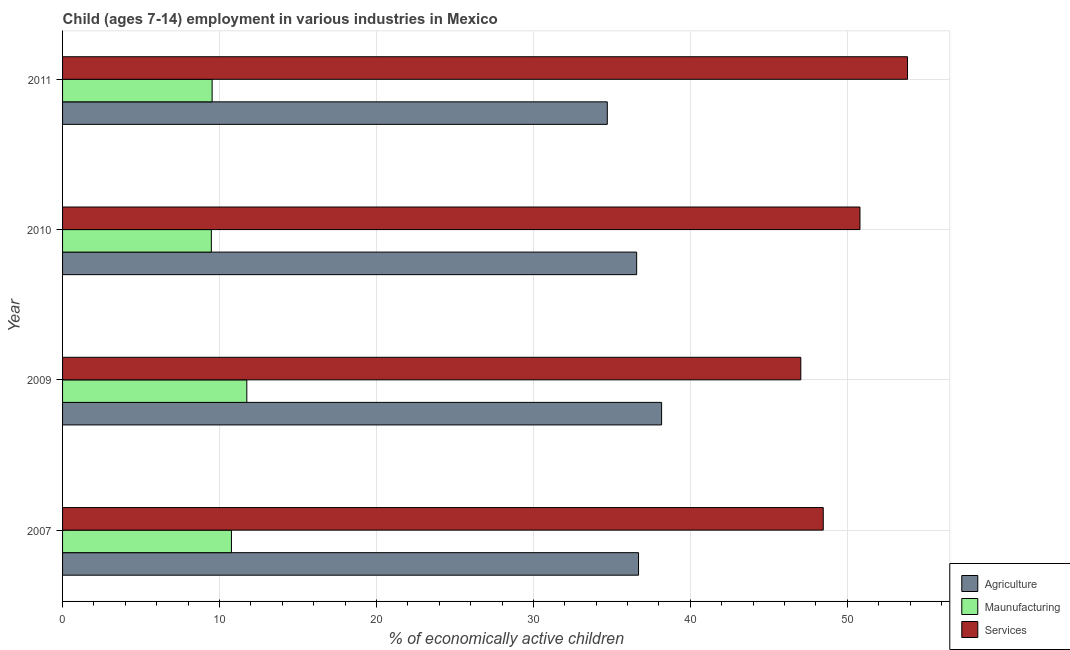Are the number of bars per tick equal to the number of legend labels?
Offer a very short reply. Yes. How many bars are there on the 3rd tick from the top?
Make the answer very short. 3. How many bars are there on the 1st tick from the bottom?
Offer a very short reply. 3. What is the label of the 3rd group of bars from the top?
Your answer should be compact. 2009. What is the percentage of economically active children in services in 2010?
Provide a succinct answer. 50.81. Across all years, what is the maximum percentage of economically active children in manufacturing?
Provide a succinct answer. 11.74. Across all years, what is the minimum percentage of economically active children in manufacturing?
Provide a short and direct response. 9.48. In which year was the percentage of economically active children in services maximum?
Your answer should be compact. 2011. What is the total percentage of economically active children in manufacturing in the graph?
Provide a short and direct response. 41.51. What is the difference between the percentage of economically active children in services in 2007 and that in 2011?
Offer a very short reply. -5.37. What is the difference between the percentage of economically active children in agriculture in 2010 and the percentage of economically active children in services in 2009?
Offer a terse response. -10.46. What is the average percentage of economically active children in manufacturing per year?
Ensure brevity in your answer.  10.38. In the year 2009, what is the difference between the percentage of economically active children in agriculture and percentage of economically active children in services?
Provide a short and direct response. -8.87. What is the ratio of the percentage of economically active children in agriculture in 2010 to that in 2011?
Make the answer very short. 1.05. Is the difference between the percentage of economically active children in services in 2009 and 2011 greater than the difference between the percentage of economically active children in manufacturing in 2009 and 2011?
Your response must be concise. No. What is the difference between the highest and the second highest percentage of economically active children in services?
Your answer should be compact. 3.03. In how many years, is the percentage of economically active children in manufacturing greater than the average percentage of economically active children in manufacturing taken over all years?
Your response must be concise. 2. What does the 3rd bar from the top in 2011 represents?
Your response must be concise. Agriculture. What does the 3rd bar from the bottom in 2010 represents?
Offer a terse response. Services. Is it the case that in every year, the sum of the percentage of economically active children in agriculture and percentage of economically active children in manufacturing is greater than the percentage of economically active children in services?
Your response must be concise. No. Are all the bars in the graph horizontal?
Your response must be concise. Yes. How many years are there in the graph?
Make the answer very short. 4. What is the difference between two consecutive major ticks on the X-axis?
Ensure brevity in your answer.  10. Are the values on the major ticks of X-axis written in scientific E-notation?
Make the answer very short. No. How many legend labels are there?
Give a very brief answer. 3. What is the title of the graph?
Your answer should be very brief. Child (ages 7-14) employment in various industries in Mexico. Does "Primary education" appear as one of the legend labels in the graph?
Make the answer very short. No. What is the label or title of the X-axis?
Give a very brief answer. % of economically active children. What is the label or title of the Y-axis?
Offer a terse response. Year. What is the % of economically active children in Agriculture in 2007?
Give a very brief answer. 36.7. What is the % of economically active children in Maunufacturing in 2007?
Ensure brevity in your answer.  10.76. What is the % of economically active children of Services in 2007?
Give a very brief answer. 48.47. What is the % of economically active children of Agriculture in 2009?
Your answer should be very brief. 38.17. What is the % of economically active children in Maunufacturing in 2009?
Offer a terse response. 11.74. What is the % of economically active children in Services in 2009?
Give a very brief answer. 47.04. What is the % of economically active children in Agriculture in 2010?
Provide a succinct answer. 36.58. What is the % of economically active children in Maunufacturing in 2010?
Offer a terse response. 9.48. What is the % of economically active children in Services in 2010?
Your answer should be very brief. 50.81. What is the % of economically active children in Agriculture in 2011?
Make the answer very short. 34.71. What is the % of economically active children of Maunufacturing in 2011?
Offer a terse response. 9.53. What is the % of economically active children in Services in 2011?
Your response must be concise. 53.84. Across all years, what is the maximum % of economically active children of Agriculture?
Offer a very short reply. 38.17. Across all years, what is the maximum % of economically active children of Maunufacturing?
Your answer should be compact. 11.74. Across all years, what is the maximum % of economically active children in Services?
Offer a very short reply. 53.84. Across all years, what is the minimum % of economically active children in Agriculture?
Your response must be concise. 34.71. Across all years, what is the minimum % of economically active children of Maunufacturing?
Offer a very short reply. 9.48. Across all years, what is the minimum % of economically active children of Services?
Make the answer very short. 47.04. What is the total % of economically active children in Agriculture in the graph?
Your response must be concise. 146.16. What is the total % of economically active children in Maunufacturing in the graph?
Provide a succinct answer. 41.51. What is the total % of economically active children of Services in the graph?
Make the answer very short. 200.16. What is the difference between the % of economically active children in Agriculture in 2007 and that in 2009?
Provide a succinct answer. -1.47. What is the difference between the % of economically active children in Maunufacturing in 2007 and that in 2009?
Your response must be concise. -0.98. What is the difference between the % of economically active children of Services in 2007 and that in 2009?
Provide a succinct answer. 1.43. What is the difference between the % of economically active children in Agriculture in 2007 and that in 2010?
Offer a terse response. 0.12. What is the difference between the % of economically active children in Maunufacturing in 2007 and that in 2010?
Give a very brief answer. 1.28. What is the difference between the % of economically active children in Services in 2007 and that in 2010?
Provide a short and direct response. -2.34. What is the difference between the % of economically active children in Agriculture in 2007 and that in 2011?
Offer a terse response. 1.99. What is the difference between the % of economically active children in Maunufacturing in 2007 and that in 2011?
Offer a very short reply. 1.23. What is the difference between the % of economically active children in Services in 2007 and that in 2011?
Your answer should be very brief. -5.37. What is the difference between the % of economically active children of Agriculture in 2009 and that in 2010?
Give a very brief answer. 1.59. What is the difference between the % of economically active children in Maunufacturing in 2009 and that in 2010?
Provide a short and direct response. 2.26. What is the difference between the % of economically active children in Services in 2009 and that in 2010?
Provide a succinct answer. -3.77. What is the difference between the % of economically active children of Agriculture in 2009 and that in 2011?
Ensure brevity in your answer.  3.46. What is the difference between the % of economically active children in Maunufacturing in 2009 and that in 2011?
Your response must be concise. 2.21. What is the difference between the % of economically active children of Agriculture in 2010 and that in 2011?
Make the answer very short. 1.87. What is the difference between the % of economically active children of Services in 2010 and that in 2011?
Provide a succinct answer. -3.03. What is the difference between the % of economically active children in Agriculture in 2007 and the % of economically active children in Maunufacturing in 2009?
Your response must be concise. 24.96. What is the difference between the % of economically active children of Agriculture in 2007 and the % of economically active children of Services in 2009?
Provide a succinct answer. -10.34. What is the difference between the % of economically active children in Maunufacturing in 2007 and the % of economically active children in Services in 2009?
Keep it short and to the point. -36.28. What is the difference between the % of economically active children of Agriculture in 2007 and the % of economically active children of Maunufacturing in 2010?
Your answer should be very brief. 27.22. What is the difference between the % of economically active children in Agriculture in 2007 and the % of economically active children in Services in 2010?
Make the answer very short. -14.11. What is the difference between the % of economically active children of Maunufacturing in 2007 and the % of economically active children of Services in 2010?
Your response must be concise. -40.05. What is the difference between the % of economically active children of Agriculture in 2007 and the % of economically active children of Maunufacturing in 2011?
Provide a succinct answer. 27.17. What is the difference between the % of economically active children of Agriculture in 2007 and the % of economically active children of Services in 2011?
Your answer should be compact. -17.14. What is the difference between the % of economically active children in Maunufacturing in 2007 and the % of economically active children in Services in 2011?
Your response must be concise. -43.08. What is the difference between the % of economically active children in Agriculture in 2009 and the % of economically active children in Maunufacturing in 2010?
Your answer should be compact. 28.69. What is the difference between the % of economically active children in Agriculture in 2009 and the % of economically active children in Services in 2010?
Make the answer very short. -12.64. What is the difference between the % of economically active children of Maunufacturing in 2009 and the % of economically active children of Services in 2010?
Provide a short and direct response. -39.07. What is the difference between the % of economically active children of Agriculture in 2009 and the % of economically active children of Maunufacturing in 2011?
Offer a terse response. 28.64. What is the difference between the % of economically active children in Agriculture in 2009 and the % of economically active children in Services in 2011?
Give a very brief answer. -15.67. What is the difference between the % of economically active children in Maunufacturing in 2009 and the % of economically active children in Services in 2011?
Offer a terse response. -42.1. What is the difference between the % of economically active children of Agriculture in 2010 and the % of economically active children of Maunufacturing in 2011?
Provide a succinct answer. 27.05. What is the difference between the % of economically active children of Agriculture in 2010 and the % of economically active children of Services in 2011?
Offer a terse response. -17.26. What is the difference between the % of economically active children of Maunufacturing in 2010 and the % of economically active children of Services in 2011?
Your answer should be compact. -44.36. What is the average % of economically active children of Agriculture per year?
Offer a very short reply. 36.54. What is the average % of economically active children of Maunufacturing per year?
Provide a short and direct response. 10.38. What is the average % of economically active children of Services per year?
Offer a terse response. 50.04. In the year 2007, what is the difference between the % of economically active children of Agriculture and % of economically active children of Maunufacturing?
Make the answer very short. 25.94. In the year 2007, what is the difference between the % of economically active children of Agriculture and % of economically active children of Services?
Offer a terse response. -11.77. In the year 2007, what is the difference between the % of economically active children of Maunufacturing and % of economically active children of Services?
Make the answer very short. -37.71. In the year 2009, what is the difference between the % of economically active children of Agriculture and % of economically active children of Maunufacturing?
Make the answer very short. 26.43. In the year 2009, what is the difference between the % of economically active children of Agriculture and % of economically active children of Services?
Make the answer very short. -8.87. In the year 2009, what is the difference between the % of economically active children of Maunufacturing and % of economically active children of Services?
Offer a very short reply. -35.3. In the year 2010, what is the difference between the % of economically active children of Agriculture and % of economically active children of Maunufacturing?
Your answer should be compact. 27.1. In the year 2010, what is the difference between the % of economically active children in Agriculture and % of economically active children in Services?
Offer a very short reply. -14.23. In the year 2010, what is the difference between the % of economically active children in Maunufacturing and % of economically active children in Services?
Give a very brief answer. -41.33. In the year 2011, what is the difference between the % of economically active children of Agriculture and % of economically active children of Maunufacturing?
Ensure brevity in your answer.  25.18. In the year 2011, what is the difference between the % of economically active children of Agriculture and % of economically active children of Services?
Make the answer very short. -19.13. In the year 2011, what is the difference between the % of economically active children of Maunufacturing and % of economically active children of Services?
Offer a very short reply. -44.31. What is the ratio of the % of economically active children of Agriculture in 2007 to that in 2009?
Offer a very short reply. 0.96. What is the ratio of the % of economically active children in Maunufacturing in 2007 to that in 2009?
Your answer should be very brief. 0.92. What is the ratio of the % of economically active children in Services in 2007 to that in 2009?
Ensure brevity in your answer.  1.03. What is the ratio of the % of economically active children of Maunufacturing in 2007 to that in 2010?
Provide a succinct answer. 1.14. What is the ratio of the % of economically active children in Services in 2007 to that in 2010?
Offer a terse response. 0.95. What is the ratio of the % of economically active children in Agriculture in 2007 to that in 2011?
Your answer should be compact. 1.06. What is the ratio of the % of economically active children in Maunufacturing in 2007 to that in 2011?
Make the answer very short. 1.13. What is the ratio of the % of economically active children of Services in 2007 to that in 2011?
Your answer should be very brief. 0.9. What is the ratio of the % of economically active children in Agriculture in 2009 to that in 2010?
Keep it short and to the point. 1.04. What is the ratio of the % of economically active children in Maunufacturing in 2009 to that in 2010?
Provide a short and direct response. 1.24. What is the ratio of the % of economically active children of Services in 2009 to that in 2010?
Ensure brevity in your answer.  0.93. What is the ratio of the % of economically active children in Agriculture in 2009 to that in 2011?
Keep it short and to the point. 1.1. What is the ratio of the % of economically active children in Maunufacturing in 2009 to that in 2011?
Offer a very short reply. 1.23. What is the ratio of the % of economically active children of Services in 2009 to that in 2011?
Keep it short and to the point. 0.87. What is the ratio of the % of economically active children of Agriculture in 2010 to that in 2011?
Give a very brief answer. 1.05. What is the ratio of the % of economically active children of Services in 2010 to that in 2011?
Offer a terse response. 0.94. What is the difference between the highest and the second highest % of economically active children of Agriculture?
Your response must be concise. 1.47. What is the difference between the highest and the second highest % of economically active children in Maunufacturing?
Your answer should be very brief. 0.98. What is the difference between the highest and the second highest % of economically active children in Services?
Offer a terse response. 3.03. What is the difference between the highest and the lowest % of economically active children in Agriculture?
Ensure brevity in your answer.  3.46. What is the difference between the highest and the lowest % of economically active children of Maunufacturing?
Provide a succinct answer. 2.26. 